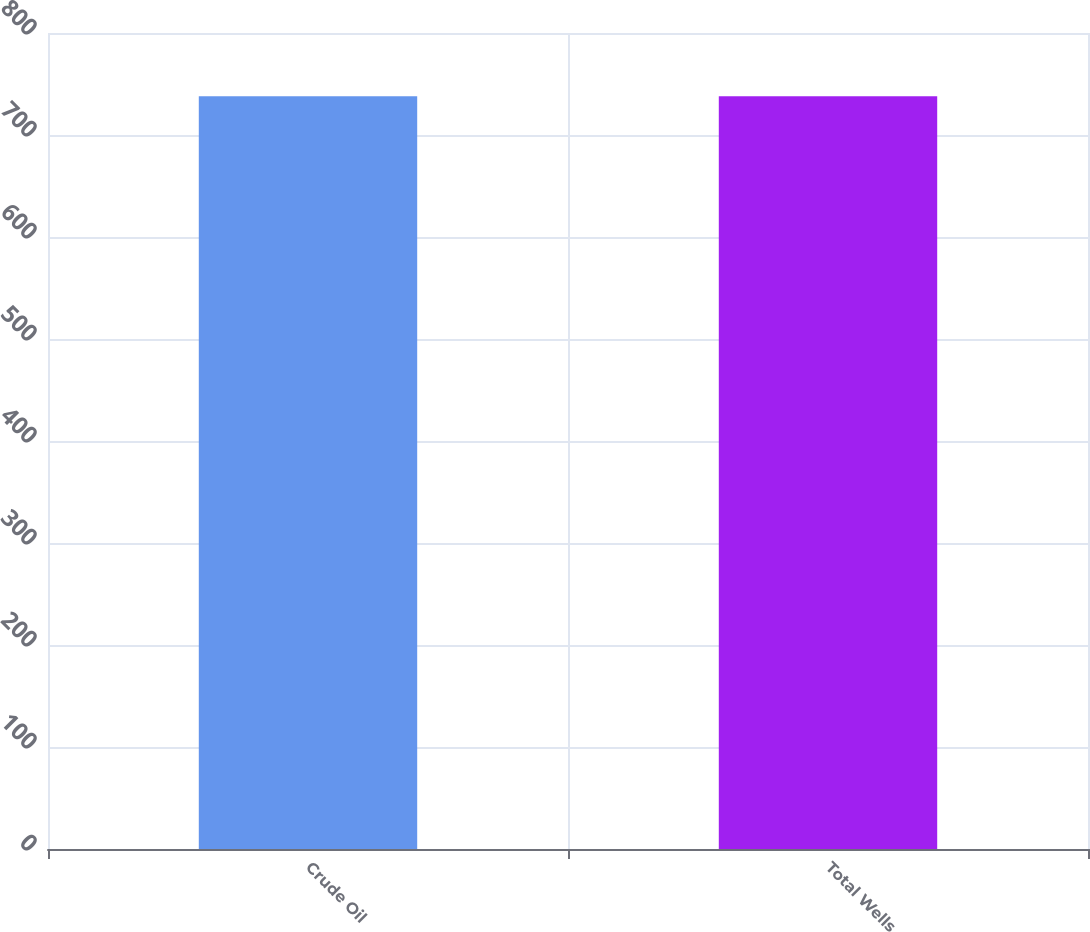Convert chart to OTSL. <chart><loc_0><loc_0><loc_500><loc_500><bar_chart><fcel>Crude Oil<fcel>Total Wells<nl><fcel>738<fcel>738.1<nl></chart> 